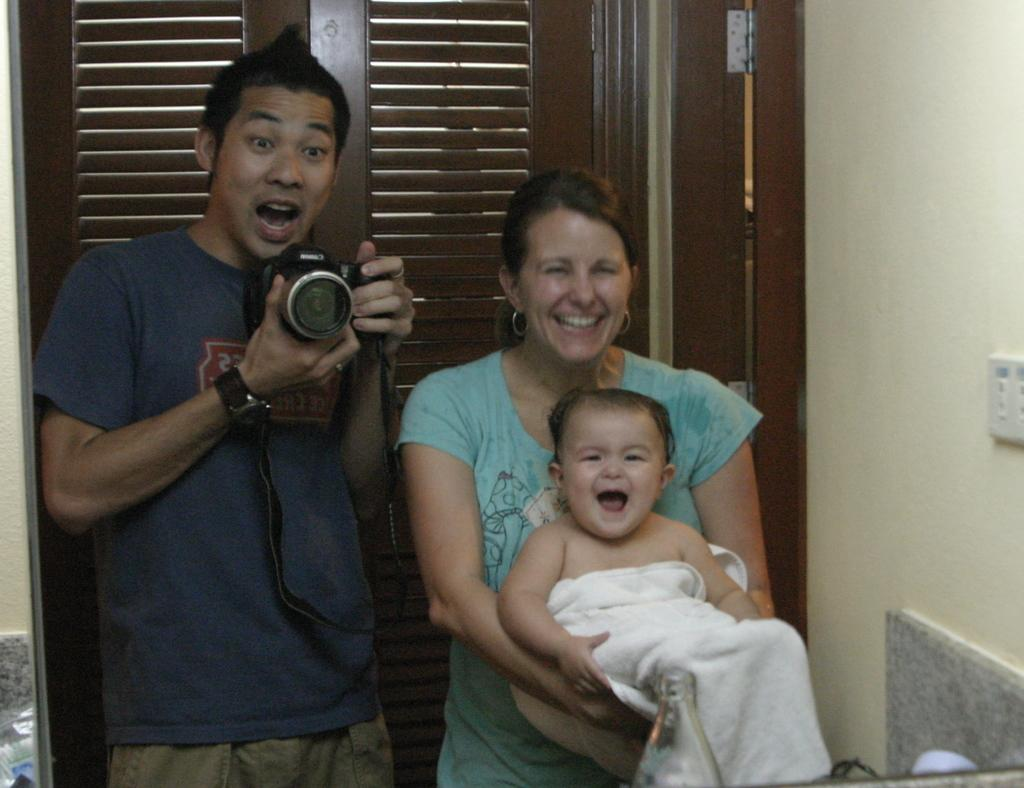What is happening in the image? There are people standing in the image. Can you describe what the man is doing? The man is holding a camera in his hand. What is the woman holding in her hand? The woman is holding a baby in her hand. What type of step is visible in the image? There is no step present in the image. What substance is the horse using to clean its hooves in the image? There is no horse present in the image. 